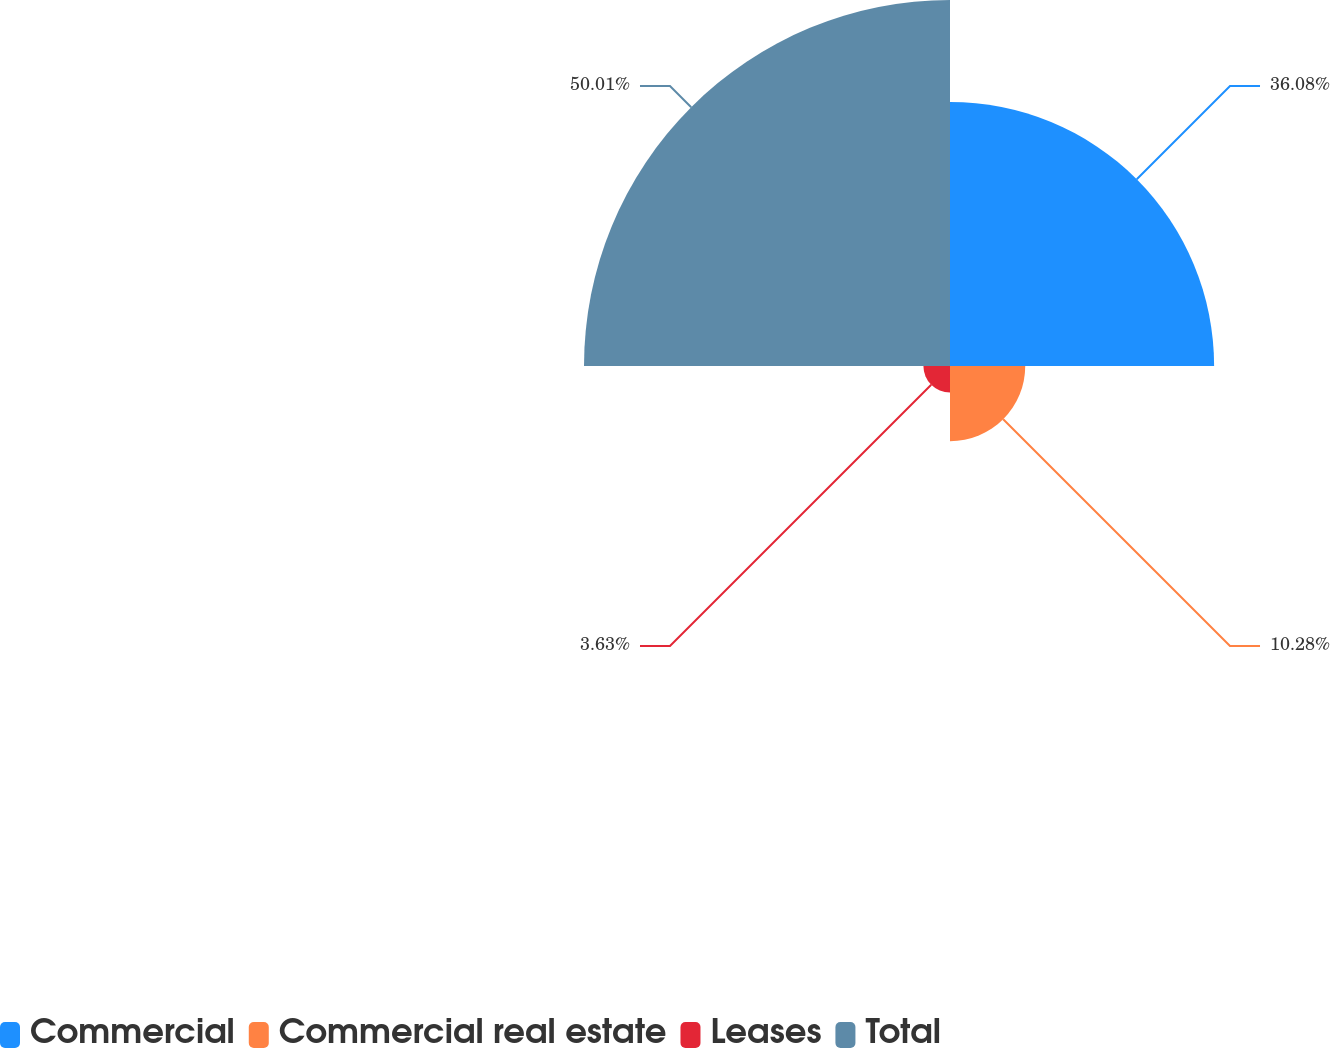Convert chart. <chart><loc_0><loc_0><loc_500><loc_500><pie_chart><fcel>Commercial<fcel>Commercial real estate<fcel>Leases<fcel>Total<nl><fcel>36.08%<fcel>10.28%<fcel>3.63%<fcel>50.0%<nl></chart> 